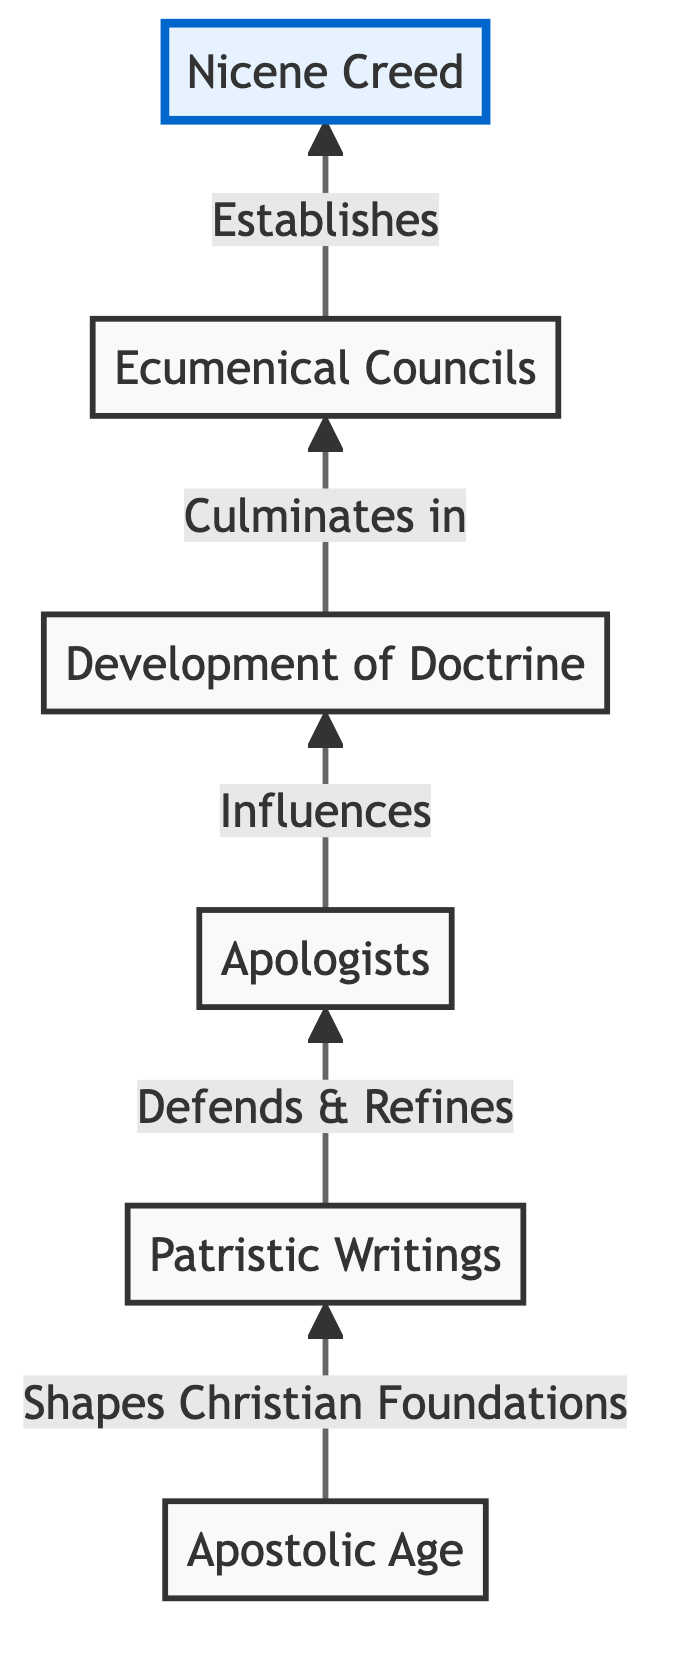What is the starting point of the flowchart? The flowchart starts with the "Apostolic Age" node, which represents the initial period of early Christianity.
Answer: Apostolic Age How many nodes are there in the diagram? By counting all the elements listed in the diagram, including the final node, there are a total of six nodes.
Answer: 6 What is the connection between "Patristic Writings" and "Apologists"? The relationship shows that the "Patristic Writings" defend and refine early Christian thought, leading to the emergence of "Apologists".
Answer: Defends & Refines Which node symbolizes the culmination of doctrinal development? The diagram indicates that the "Ecumenical Councils" node represents the culmination of the development of doctrine.
Answer: Ecumenical Councils What foundational beliefs are established by the final node? The "Nicene Creed" node at the top of the diagram establishes foundational Christian beliefs related to the nature of Jesus Christ and the Trinity.
Answer: Foundational Christian beliefs What process connects "Apologists" to "Development of Doctrine"? The diagram illustrates that “Apologists” influence the "Development of Doctrine" through their theological defenses and writings.
Answer: Influences Which two nodes are directly connected to "Ecumenical Councils"? The nodes that connect directly to "Ecumenical Councils" are "Development of Doctrine" and "Nicene Creed".
Answer: Development of Doctrine and Nicene Creed How does the structure of the diagram facilitate understanding of theological progression? The bottom-to-top structure clearly shows the progression from the Apostolic Age through various stages of theological development to the final product, illustrating how they build upon one another.
Answer: Progression in theology What does the highlighted node represent in the diagram? The highlighted node at the top, "Nicene Creed," represents the final established beliefs of early Christianity as formulated at the First Council of Nicaea.
Answer: Nicene Creed 